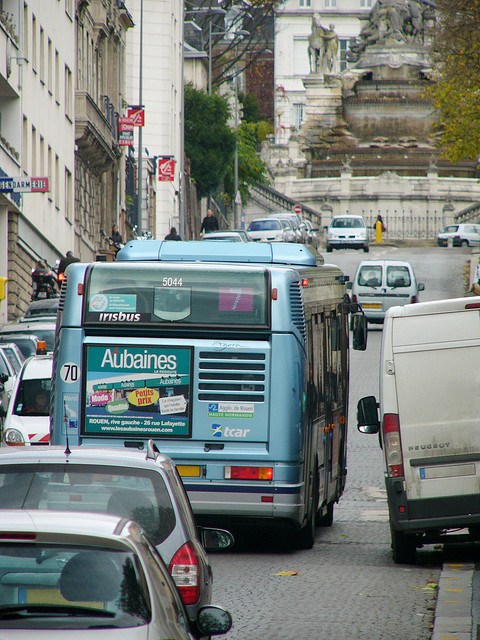Please extract the text content from this image. risbus 5044 Aubaines 70 